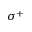Convert formula to latex. <formula><loc_0><loc_0><loc_500><loc_500>\sigma ^ { + }</formula> 